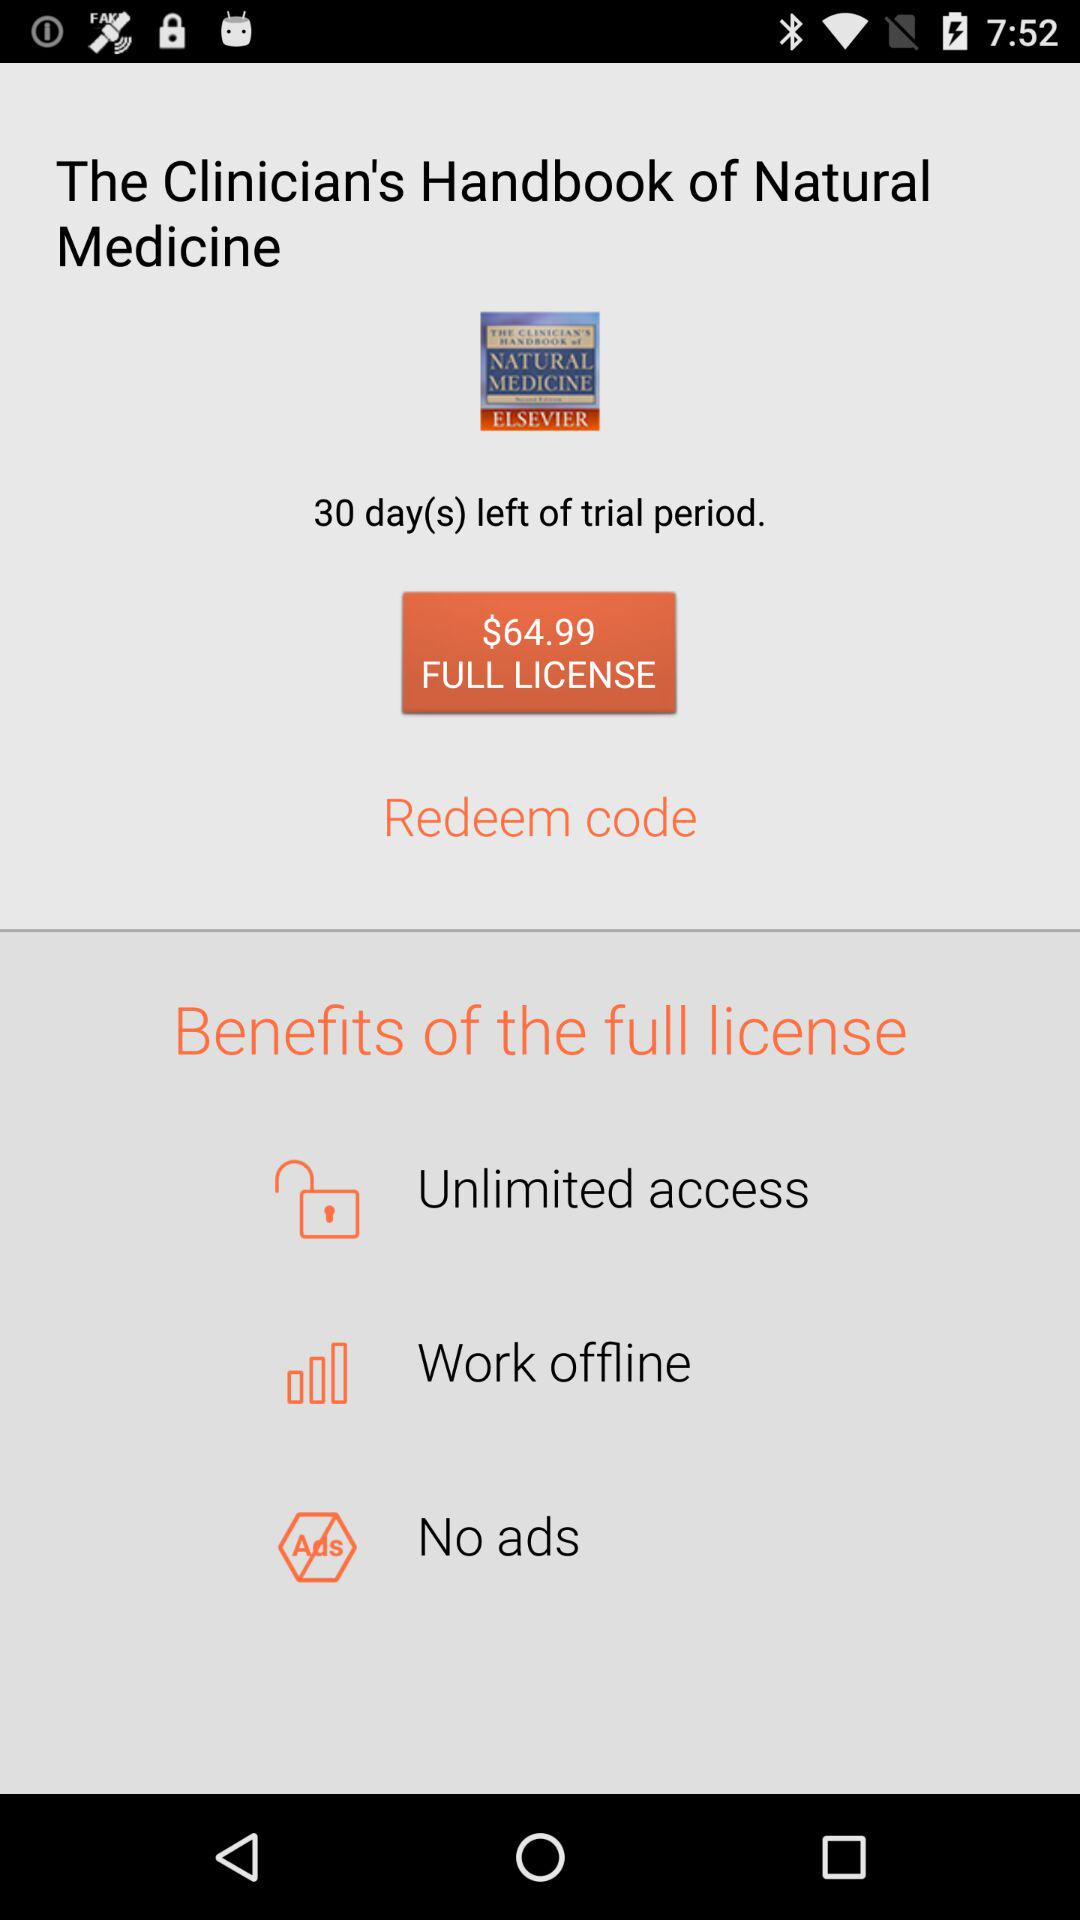How many days are left of the trial period of "The Clinician's Handbook of Natural Medicine"? There are 30 days left. 